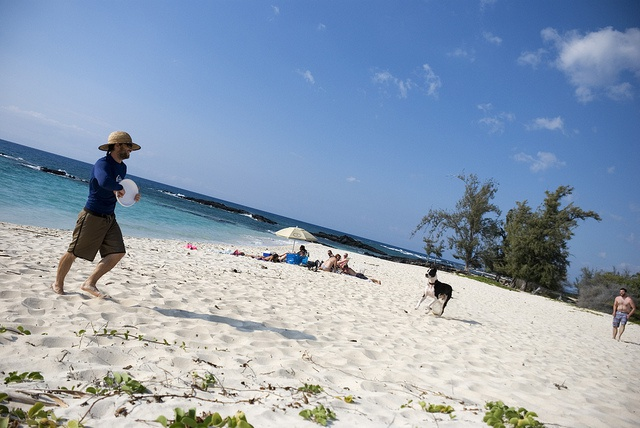Describe the objects in this image and their specific colors. I can see people in gray, black, maroon, and darkgray tones, dog in gray, black, darkgray, and lightgray tones, people in gray, darkgray, and pink tones, frisbee in gray and darkgray tones, and umbrella in gray, beige, darkgray, and lightgray tones in this image. 